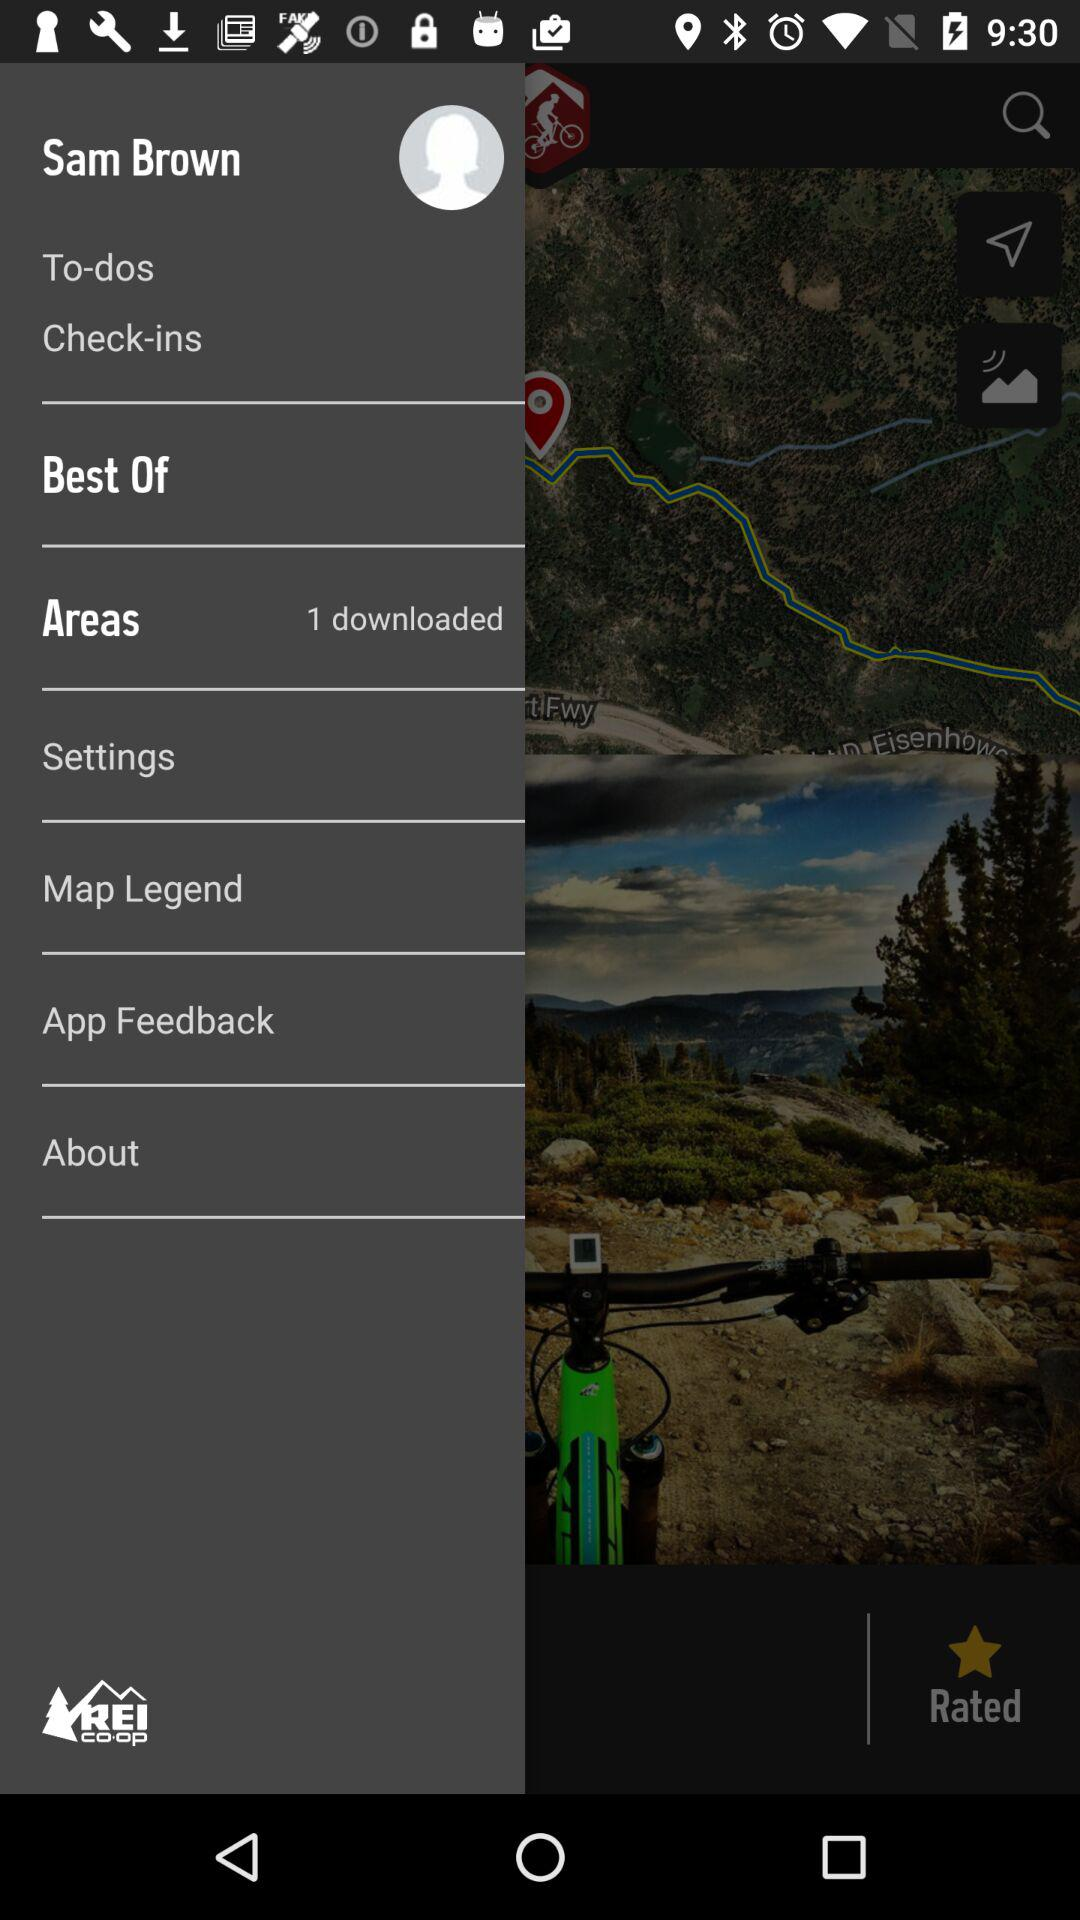How many downloaded items are in "Areas"? There is 1 item downloaded in "Areas". 